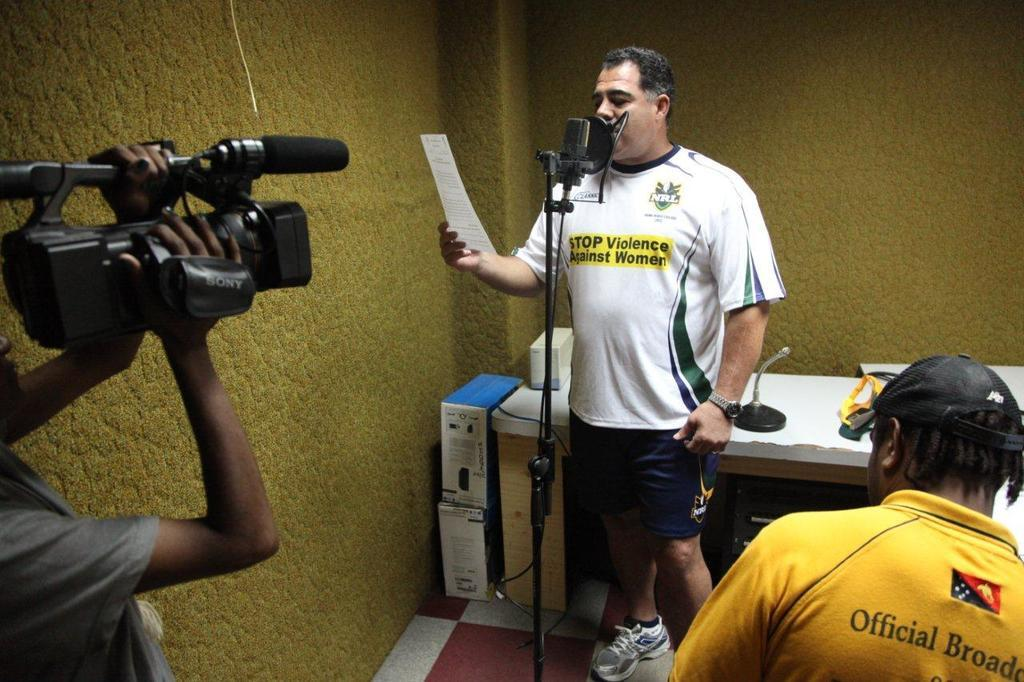Provide a one-sentence caption for the provided image. A recording of a message to promote nonviolence against women. 